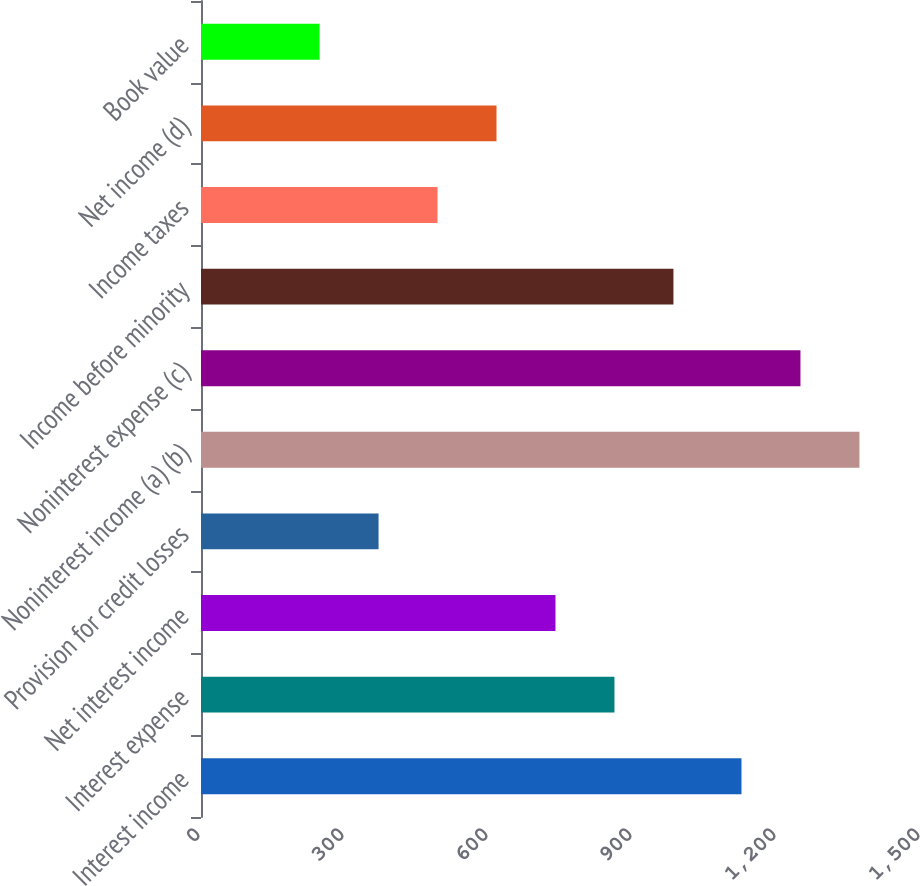Convert chart. <chart><loc_0><loc_0><loc_500><loc_500><bar_chart><fcel>Interest income<fcel>Interest expense<fcel>Net interest income<fcel>Provision for credit losses<fcel>Noninterest income (a) (b)<fcel>Noninterest expense (c)<fcel>Income before minority<fcel>Income taxes<fcel>Net income (d)<fcel>Book value<nl><fcel>1126<fcel>861.37<fcel>738.5<fcel>369.89<fcel>1371.74<fcel>1248.87<fcel>984.24<fcel>492.76<fcel>615.63<fcel>247.02<nl></chart> 